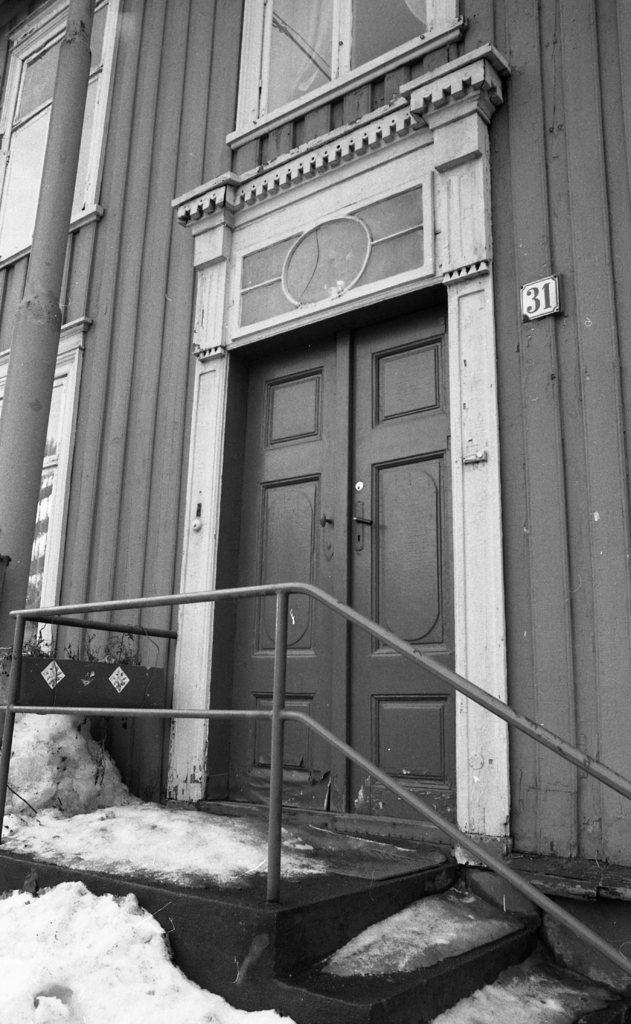What type of architectural feature can be seen in the image? There are steps in the image. What is the weather like in the image? There is snow in the image, indicating a cold or wintery environment. What type of openings are present in the image? There are doors and windows with curtains in the image. What other object can be seen in the image? There is a pole in the image. What type of barrier is visible in the image? There is a wall in the image. What type of soda is being served at the father's birthday party in the image? There is no father or birthday party present in the image, and therefore no soda being served. What type of advice does the dad give to his children in the image? There is no dad or children present in the image, so no advice can be given. 